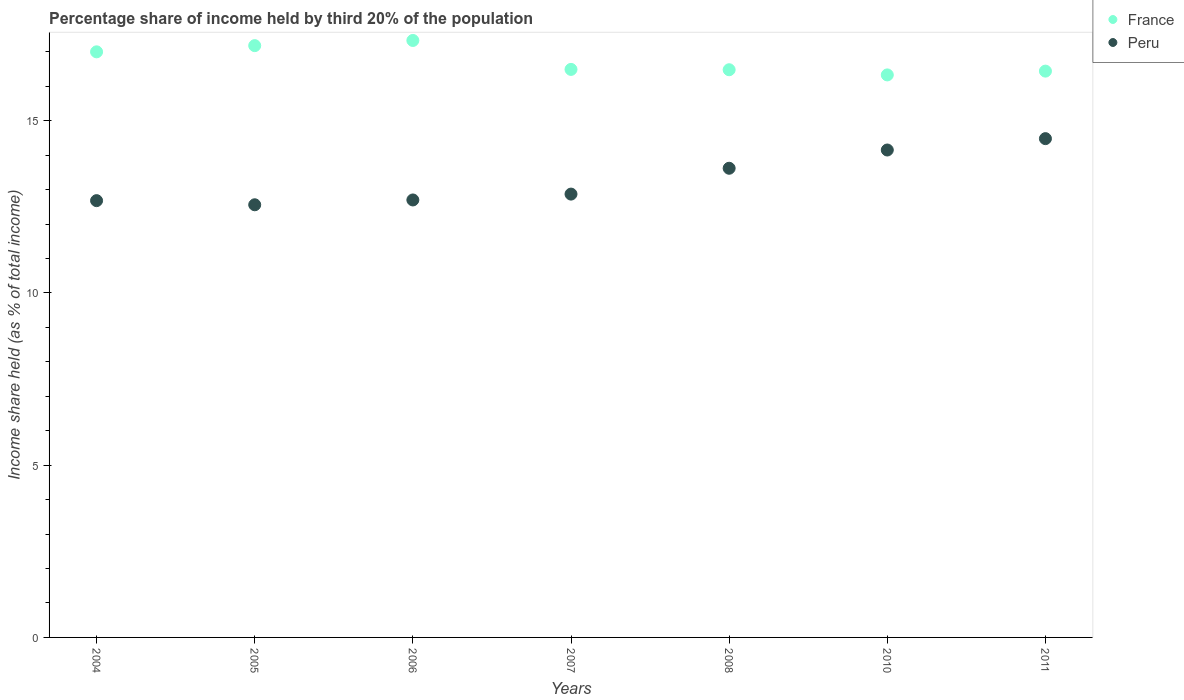Is the number of dotlines equal to the number of legend labels?
Your answer should be very brief. Yes. What is the share of income held by third 20% of the population in Peru in 2008?
Give a very brief answer. 13.62. Across all years, what is the maximum share of income held by third 20% of the population in Peru?
Your response must be concise. 14.48. Across all years, what is the minimum share of income held by third 20% of the population in Peru?
Offer a very short reply. 12.56. In which year was the share of income held by third 20% of the population in Peru minimum?
Give a very brief answer. 2005. What is the total share of income held by third 20% of the population in France in the graph?
Give a very brief answer. 117.25. What is the difference between the share of income held by third 20% of the population in Peru in 2006 and that in 2010?
Offer a very short reply. -1.45. What is the difference between the share of income held by third 20% of the population in Peru in 2011 and the share of income held by third 20% of the population in France in 2007?
Give a very brief answer. -2.01. What is the average share of income held by third 20% of the population in Peru per year?
Your answer should be very brief. 13.29. In the year 2007, what is the difference between the share of income held by third 20% of the population in France and share of income held by third 20% of the population in Peru?
Provide a succinct answer. 3.62. What is the ratio of the share of income held by third 20% of the population in France in 2005 to that in 2010?
Your response must be concise. 1.05. Is the share of income held by third 20% of the population in Peru in 2006 less than that in 2007?
Your response must be concise. Yes. Is the difference between the share of income held by third 20% of the population in France in 2005 and 2011 greater than the difference between the share of income held by third 20% of the population in Peru in 2005 and 2011?
Keep it short and to the point. Yes. What is the difference between the highest and the second highest share of income held by third 20% of the population in Peru?
Your answer should be compact. 0.33. What is the difference between the highest and the lowest share of income held by third 20% of the population in Peru?
Ensure brevity in your answer.  1.92. In how many years, is the share of income held by third 20% of the population in France greater than the average share of income held by third 20% of the population in France taken over all years?
Provide a short and direct response. 3. Is the sum of the share of income held by third 20% of the population in Peru in 2004 and 2007 greater than the maximum share of income held by third 20% of the population in France across all years?
Keep it short and to the point. Yes. How many dotlines are there?
Your answer should be very brief. 2. How many years are there in the graph?
Your answer should be very brief. 7. Are the values on the major ticks of Y-axis written in scientific E-notation?
Your answer should be compact. No. Does the graph contain any zero values?
Make the answer very short. No. Does the graph contain grids?
Give a very brief answer. No. How are the legend labels stacked?
Give a very brief answer. Vertical. What is the title of the graph?
Offer a terse response. Percentage share of income held by third 20% of the population. Does "Gambia, The" appear as one of the legend labels in the graph?
Your answer should be compact. No. What is the label or title of the Y-axis?
Your answer should be very brief. Income share held (as % of total income). What is the Income share held (as % of total income) of France in 2004?
Make the answer very short. 17. What is the Income share held (as % of total income) in Peru in 2004?
Offer a terse response. 12.68. What is the Income share held (as % of total income) of France in 2005?
Ensure brevity in your answer.  17.18. What is the Income share held (as % of total income) of Peru in 2005?
Offer a very short reply. 12.56. What is the Income share held (as % of total income) of France in 2006?
Your answer should be very brief. 17.33. What is the Income share held (as % of total income) of Peru in 2006?
Provide a succinct answer. 12.7. What is the Income share held (as % of total income) in France in 2007?
Keep it short and to the point. 16.49. What is the Income share held (as % of total income) of Peru in 2007?
Provide a short and direct response. 12.87. What is the Income share held (as % of total income) in France in 2008?
Make the answer very short. 16.48. What is the Income share held (as % of total income) in Peru in 2008?
Keep it short and to the point. 13.62. What is the Income share held (as % of total income) in France in 2010?
Your response must be concise. 16.33. What is the Income share held (as % of total income) in Peru in 2010?
Give a very brief answer. 14.15. What is the Income share held (as % of total income) in France in 2011?
Provide a succinct answer. 16.44. What is the Income share held (as % of total income) in Peru in 2011?
Ensure brevity in your answer.  14.48. Across all years, what is the maximum Income share held (as % of total income) of France?
Give a very brief answer. 17.33. Across all years, what is the maximum Income share held (as % of total income) of Peru?
Make the answer very short. 14.48. Across all years, what is the minimum Income share held (as % of total income) in France?
Provide a short and direct response. 16.33. Across all years, what is the minimum Income share held (as % of total income) in Peru?
Your response must be concise. 12.56. What is the total Income share held (as % of total income) of France in the graph?
Your answer should be compact. 117.25. What is the total Income share held (as % of total income) of Peru in the graph?
Your answer should be very brief. 93.06. What is the difference between the Income share held (as % of total income) in France in 2004 and that in 2005?
Make the answer very short. -0.18. What is the difference between the Income share held (as % of total income) of Peru in 2004 and that in 2005?
Provide a succinct answer. 0.12. What is the difference between the Income share held (as % of total income) of France in 2004 and that in 2006?
Keep it short and to the point. -0.33. What is the difference between the Income share held (as % of total income) of Peru in 2004 and that in 2006?
Provide a short and direct response. -0.02. What is the difference between the Income share held (as % of total income) in France in 2004 and that in 2007?
Provide a succinct answer. 0.51. What is the difference between the Income share held (as % of total income) of Peru in 2004 and that in 2007?
Your answer should be compact. -0.19. What is the difference between the Income share held (as % of total income) of France in 2004 and that in 2008?
Provide a succinct answer. 0.52. What is the difference between the Income share held (as % of total income) of Peru in 2004 and that in 2008?
Provide a succinct answer. -0.94. What is the difference between the Income share held (as % of total income) of France in 2004 and that in 2010?
Ensure brevity in your answer.  0.67. What is the difference between the Income share held (as % of total income) in Peru in 2004 and that in 2010?
Your answer should be compact. -1.47. What is the difference between the Income share held (as % of total income) in France in 2004 and that in 2011?
Keep it short and to the point. 0.56. What is the difference between the Income share held (as % of total income) of Peru in 2004 and that in 2011?
Your response must be concise. -1.8. What is the difference between the Income share held (as % of total income) in France in 2005 and that in 2006?
Your response must be concise. -0.15. What is the difference between the Income share held (as % of total income) in Peru in 2005 and that in 2006?
Provide a succinct answer. -0.14. What is the difference between the Income share held (as % of total income) of France in 2005 and that in 2007?
Offer a very short reply. 0.69. What is the difference between the Income share held (as % of total income) of Peru in 2005 and that in 2007?
Provide a short and direct response. -0.31. What is the difference between the Income share held (as % of total income) of France in 2005 and that in 2008?
Give a very brief answer. 0.7. What is the difference between the Income share held (as % of total income) of Peru in 2005 and that in 2008?
Offer a very short reply. -1.06. What is the difference between the Income share held (as % of total income) in Peru in 2005 and that in 2010?
Give a very brief answer. -1.59. What is the difference between the Income share held (as % of total income) in France in 2005 and that in 2011?
Your answer should be very brief. 0.74. What is the difference between the Income share held (as % of total income) in Peru in 2005 and that in 2011?
Offer a terse response. -1.92. What is the difference between the Income share held (as % of total income) of France in 2006 and that in 2007?
Your answer should be compact. 0.84. What is the difference between the Income share held (as % of total income) in Peru in 2006 and that in 2007?
Offer a very short reply. -0.17. What is the difference between the Income share held (as % of total income) of Peru in 2006 and that in 2008?
Ensure brevity in your answer.  -0.92. What is the difference between the Income share held (as % of total income) in Peru in 2006 and that in 2010?
Ensure brevity in your answer.  -1.45. What is the difference between the Income share held (as % of total income) in France in 2006 and that in 2011?
Give a very brief answer. 0.89. What is the difference between the Income share held (as % of total income) in Peru in 2006 and that in 2011?
Your answer should be compact. -1.78. What is the difference between the Income share held (as % of total income) in France in 2007 and that in 2008?
Ensure brevity in your answer.  0.01. What is the difference between the Income share held (as % of total income) in Peru in 2007 and that in 2008?
Your response must be concise. -0.75. What is the difference between the Income share held (as % of total income) in France in 2007 and that in 2010?
Your answer should be compact. 0.16. What is the difference between the Income share held (as % of total income) of Peru in 2007 and that in 2010?
Your answer should be compact. -1.28. What is the difference between the Income share held (as % of total income) in Peru in 2007 and that in 2011?
Provide a short and direct response. -1.61. What is the difference between the Income share held (as % of total income) of Peru in 2008 and that in 2010?
Provide a succinct answer. -0.53. What is the difference between the Income share held (as % of total income) in Peru in 2008 and that in 2011?
Your response must be concise. -0.86. What is the difference between the Income share held (as % of total income) in France in 2010 and that in 2011?
Provide a short and direct response. -0.11. What is the difference between the Income share held (as % of total income) of Peru in 2010 and that in 2011?
Your answer should be compact. -0.33. What is the difference between the Income share held (as % of total income) in France in 2004 and the Income share held (as % of total income) in Peru in 2005?
Give a very brief answer. 4.44. What is the difference between the Income share held (as % of total income) in France in 2004 and the Income share held (as % of total income) in Peru in 2006?
Your answer should be compact. 4.3. What is the difference between the Income share held (as % of total income) of France in 2004 and the Income share held (as % of total income) of Peru in 2007?
Offer a terse response. 4.13. What is the difference between the Income share held (as % of total income) of France in 2004 and the Income share held (as % of total income) of Peru in 2008?
Offer a terse response. 3.38. What is the difference between the Income share held (as % of total income) in France in 2004 and the Income share held (as % of total income) in Peru in 2010?
Offer a very short reply. 2.85. What is the difference between the Income share held (as % of total income) in France in 2004 and the Income share held (as % of total income) in Peru in 2011?
Keep it short and to the point. 2.52. What is the difference between the Income share held (as % of total income) of France in 2005 and the Income share held (as % of total income) of Peru in 2006?
Provide a short and direct response. 4.48. What is the difference between the Income share held (as % of total income) in France in 2005 and the Income share held (as % of total income) in Peru in 2007?
Your response must be concise. 4.31. What is the difference between the Income share held (as % of total income) of France in 2005 and the Income share held (as % of total income) of Peru in 2008?
Give a very brief answer. 3.56. What is the difference between the Income share held (as % of total income) in France in 2005 and the Income share held (as % of total income) in Peru in 2010?
Provide a short and direct response. 3.03. What is the difference between the Income share held (as % of total income) of France in 2006 and the Income share held (as % of total income) of Peru in 2007?
Offer a very short reply. 4.46. What is the difference between the Income share held (as % of total income) of France in 2006 and the Income share held (as % of total income) of Peru in 2008?
Make the answer very short. 3.71. What is the difference between the Income share held (as % of total income) in France in 2006 and the Income share held (as % of total income) in Peru in 2010?
Your answer should be compact. 3.18. What is the difference between the Income share held (as % of total income) in France in 2006 and the Income share held (as % of total income) in Peru in 2011?
Give a very brief answer. 2.85. What is the difference between the Income share held (as % of total income) of France in 2007 and the Income share held (as % of total income) of Peru in 2008?
Make the answer very short. 2.87. What is the difference between the Income share held (as % of total income) of France in 2007 and the Income share held (as % of total income) of Peru in 2010?
Provide a succinct answer. 2.34. What is the difference between the Income share held (as % of total income) of France in 2007 and the Income share held (as % of total income) of Peru in 2011?
Make the answer very short. 2.01. What is the difference between the Income share held (as % of total income) of France in 2008 and the Income share held (as % of total income) of Peru in 2010?
Provide a short and direct response. 2.33. What is the difference between the Income share held (as % of total income) in France in 2010 and the Income share held (as % of total income) in Peru in 2011?
Provide a succinct answer. 1.85. What is the average Income share held (as % of total income) of France per year?
Give a very brief answer. 16.75. What is the average Income share held (as % of total income) in Peru per year?
Provide a succinct answer. 13.29. In the year 2004, what is the difference between the Income share held (as % of total income) in France and Income share held (as % of total income) in Peru?
Your response must be concise. 4.32. In the year 2005, what is the difference between the Income share held (as % of total income) in France and Income share held (as % of total income) in Peru?
Your answer should be very brief. 4.62. In the year 2006, what is the difference between the Income share held (as % of total income) of France and Income share held (as % of total income) of Peru?
Your response must be concise. 4.63. In the year 2007, what is the difference between the Income share held (as % of total income) of France and Income share held (as % of total income) of Peru?
Provide a succinct answer. 3.62. In the year 2008, what is the difference between the Income share held (as % of total income) in France and Income share held (as % of total income) in Peru?
Provide a short and direct response. 2.86. In the year 2010, what is the difference between the Income share held (as % of total income) in France and Income share held (as % of total income) in Peru?
Your response must be concise. 2.18. In the year 2011, what is the difference between the Income share held (as % of total income) in France and Income share held (as % of total income) in Peru?
Offer a very short reply. 1.96. What is the ratio of the Income share held (as % of total income) in France in 2004 to that in 2005?
Your response must be concise. 0.99. What is the ratio of the Income share held (as % of total income) in Peru in 2004 to that in 2005?
Offer a very short reply. 1.01. What is the ratio of the Income share held (as % of total income) in Peru in 2004 to that in 2006?
Provide a short and direct response. 1. What is the ratio of the Income share held (as % of total income) in France in 2004 to that in 2007?
Provide a succinct answer. 1.03. What is the ratio of the Income share held (as % of total income) of Peru in 2004 to that in 2007?
Your answer should be compact. 0.99. What is the ratio of the Income share held (as % of total income) of France in 2004 to that in 2008?
Keep it short and to the point. 1.03. What is the ratio of the Income share held (as % of total income) in France in 2004 to that in 2010?
Your answer should be very brief. 1.04. What is the ratio of the Income share held (as % of total income) in Peru in 2004 to that in 2010?
Provide a short and direct response. 0.9. What is the ratio of the Income share held (as % of total income) of France in 2004 to that in 2011?
Your answer should be very brief. 1.03. What is the ratio of the Income share held (as % of total income) of Peru in 2004 to that in 2011?
Provide a short and direct response. 0.88. What is the ratio of the Income share held (as % of total income) of France in 2005 to that in 2007?
Offer a very short reply. 1.04. What is the ratio of the Income share held (as % of total income) of Peru in 2005 to that in 2007?
Ensure brevity in your answer.  0.98. What is the ratio of the Income share held (as % of total income) in France in 2005 to that in 2008?
Offer a terse response. 1.04. What is the ratio of the Income share held (as % of total income) in Peru in 2005 to that in 2008?
Offer a very short reply. 0.92. What is the ratio of the Income share held (as % of total income) in France in 2005 to that in 2010?
Give a very brief answer. 1.05. What is the ratio of the Income share held (as % of total income) in Peru in 2005 to that in 2010?
Your answer should be compact. 0.89. What is the ratio of the Income share held (as % of total income) of France in 2005 to that in 2011?
Give a very brief answer. 1.04. What is the ratio of the Income share held (as % of total income) in Peru in 2005 to that in 2011?
Your answer should be very brief. 0.87. What is the ratio of the Income share held (as % of total income) of France in 2006 to that in 2007?
Your answer should be compact. 1.05. What is the ratio of the Income share held (as % of total income) of Peru in 2006 to that in 2007?
Offer a terse response. 0.99. What is the ratio of the Income share held (as % of total income) of France in 2006 to that in 2008?
Your answer should be compact. 1.05. What is the ratio of the Income share held (as % of total income) in Peru in 2006 to that in 2008?
Your response must be concise. 0.93. What is the ratio of the Income share held (as % of total income) in France in 2006 to that in 2010?
Provide a short and direct response. 1.06. What is the ratio of the Income share held (as % of total income) of Peru in 2006 to that in 2010?
Ensure brevity in your answer.  0.9. What is the ratio of the Income share held (as % of total income) in France in 2006 to that in 2011?
Give a very brief answer. 1.05. What is the ratio of the Income share held (as % of total income) in Peru in 2006 to that in 2011?
Keep it short and to the point. 0.88. What is the ratio of the Income share held (as % of total income) of France in 2007 to that in 2008?
Offer a very short reply. 1. What is the ratio of the Income share held (as % of total income) of Peru in 2007 to that in 2008?
Ensure brevity in your answer.  0.94. What is the ratio of the Income share held (as % of total income) of France in 2007 to that in 2010?
Your response must be concise. 1.01. What is the ratio of the Income share held (as % of total income) in Peru in 2007 to that in 2010?
Ensure brevity in your answer.  0.91. What is the ratio of the Income share held (as % of total income) of Peru in 2007 to that in 2011?
Ensure brevity in your answer.  0.89. What is the ratio of the Income share held (as % of total income) of France in 2008 to that in 2010?
Your answer should be very brief. 1.01. What is the ratio of the Income share held (as % of total income) of Peru in 2008 to that in 2010?
Your answer should be very brief. 0.96. What is the ratio of the Income share held (as % of total income) in France in 2008 to that in 2011?
Offer a very short reply. 1. What is the ratio of the Income share held (as % of total income) in Peru in 2008 to that in 2011?
Provide a short and direct response. 0.94. What is the ratio of the Income share held (as % of total income) in Peru in 2010 to that in 2011?
Offer a terse response. 0.98. What is the difference between the highest and the second highest Income share held (as % of total income) in Peru?
Offer a very short reply. 0.33. What is the difference between the highest and the lowest Income share held (as % of total income) of France?
Offer a very short reply. 1. What is the difference between the highest and the lowest Income share held (as % of total income) in Peru?
Give a very brief answer. 1.92. 